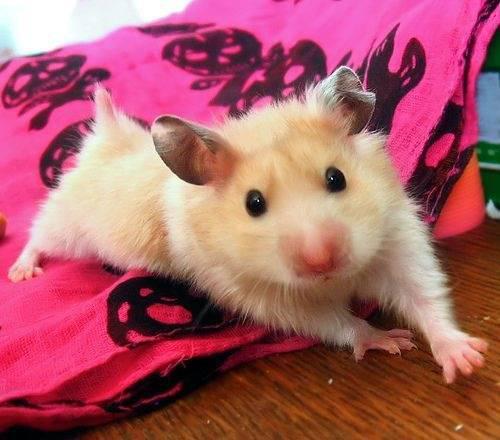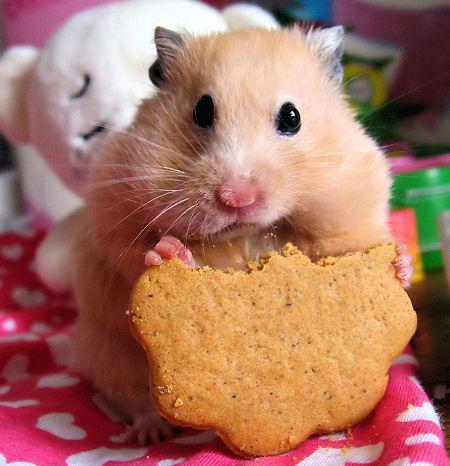The first image is the image on the left, the second image is the image on the right. For the images shown, is this caption "The hamster on the left grasps a square treat ready to munch." true? Answer yes or no. No. 